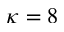Convert formula to latex. <formula><loc_0><loc_0><loc_500><loc_500>\kappa = 8</formula> 